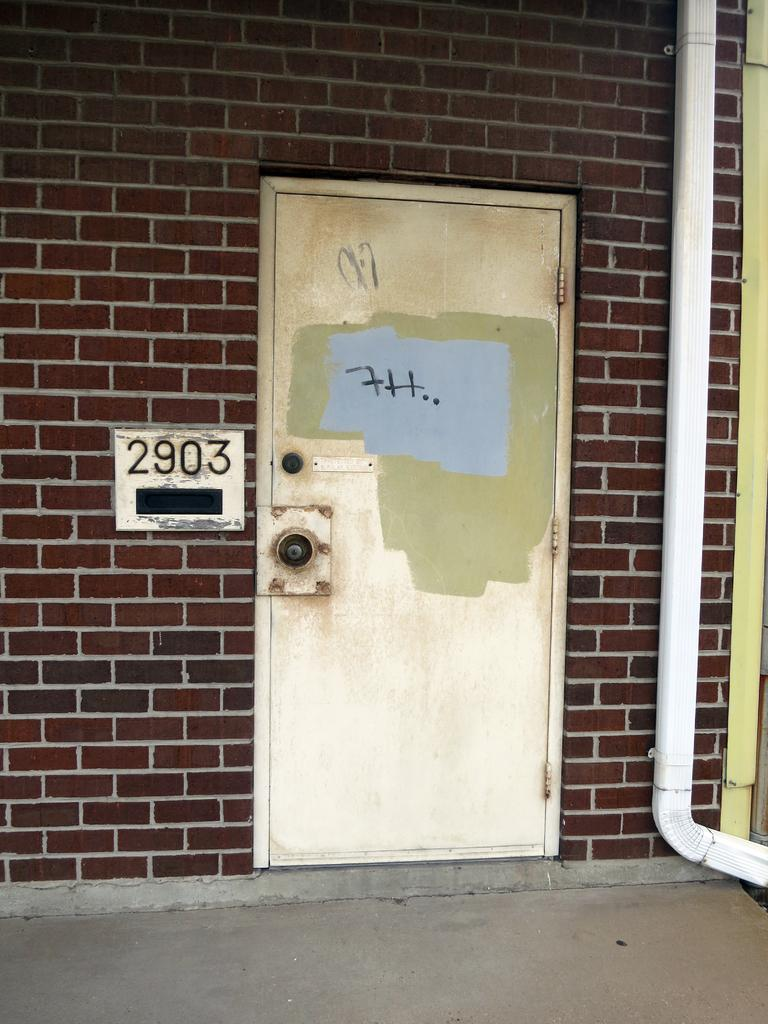What is the main object in the image? There is a door in the image. What can be seen on the left side of the image? There is a board with numbers on a wall on the left side of the image. What is present on the right side of the image? There is a pipe on the right side of the image. How many cherries are hanging from the pipe in the image? There are no cherries present in the image, and therefore no such activity can be observed. 